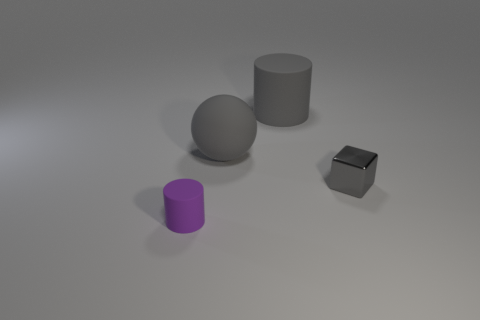Add 4 large rubber cylinders. How many objects exist? 8 Subtract all blocks. How many objects are left? 3 Subtract 0 blue cylinders. How many objects are left? 4 Subtract all tiny objects. Subtract all gray spheres. How many objects are left? 1 Add 1 large gray cylinders. How many large gray cylinders are left? 2 Add 2 gray balls. How many gray balls exist? 3 